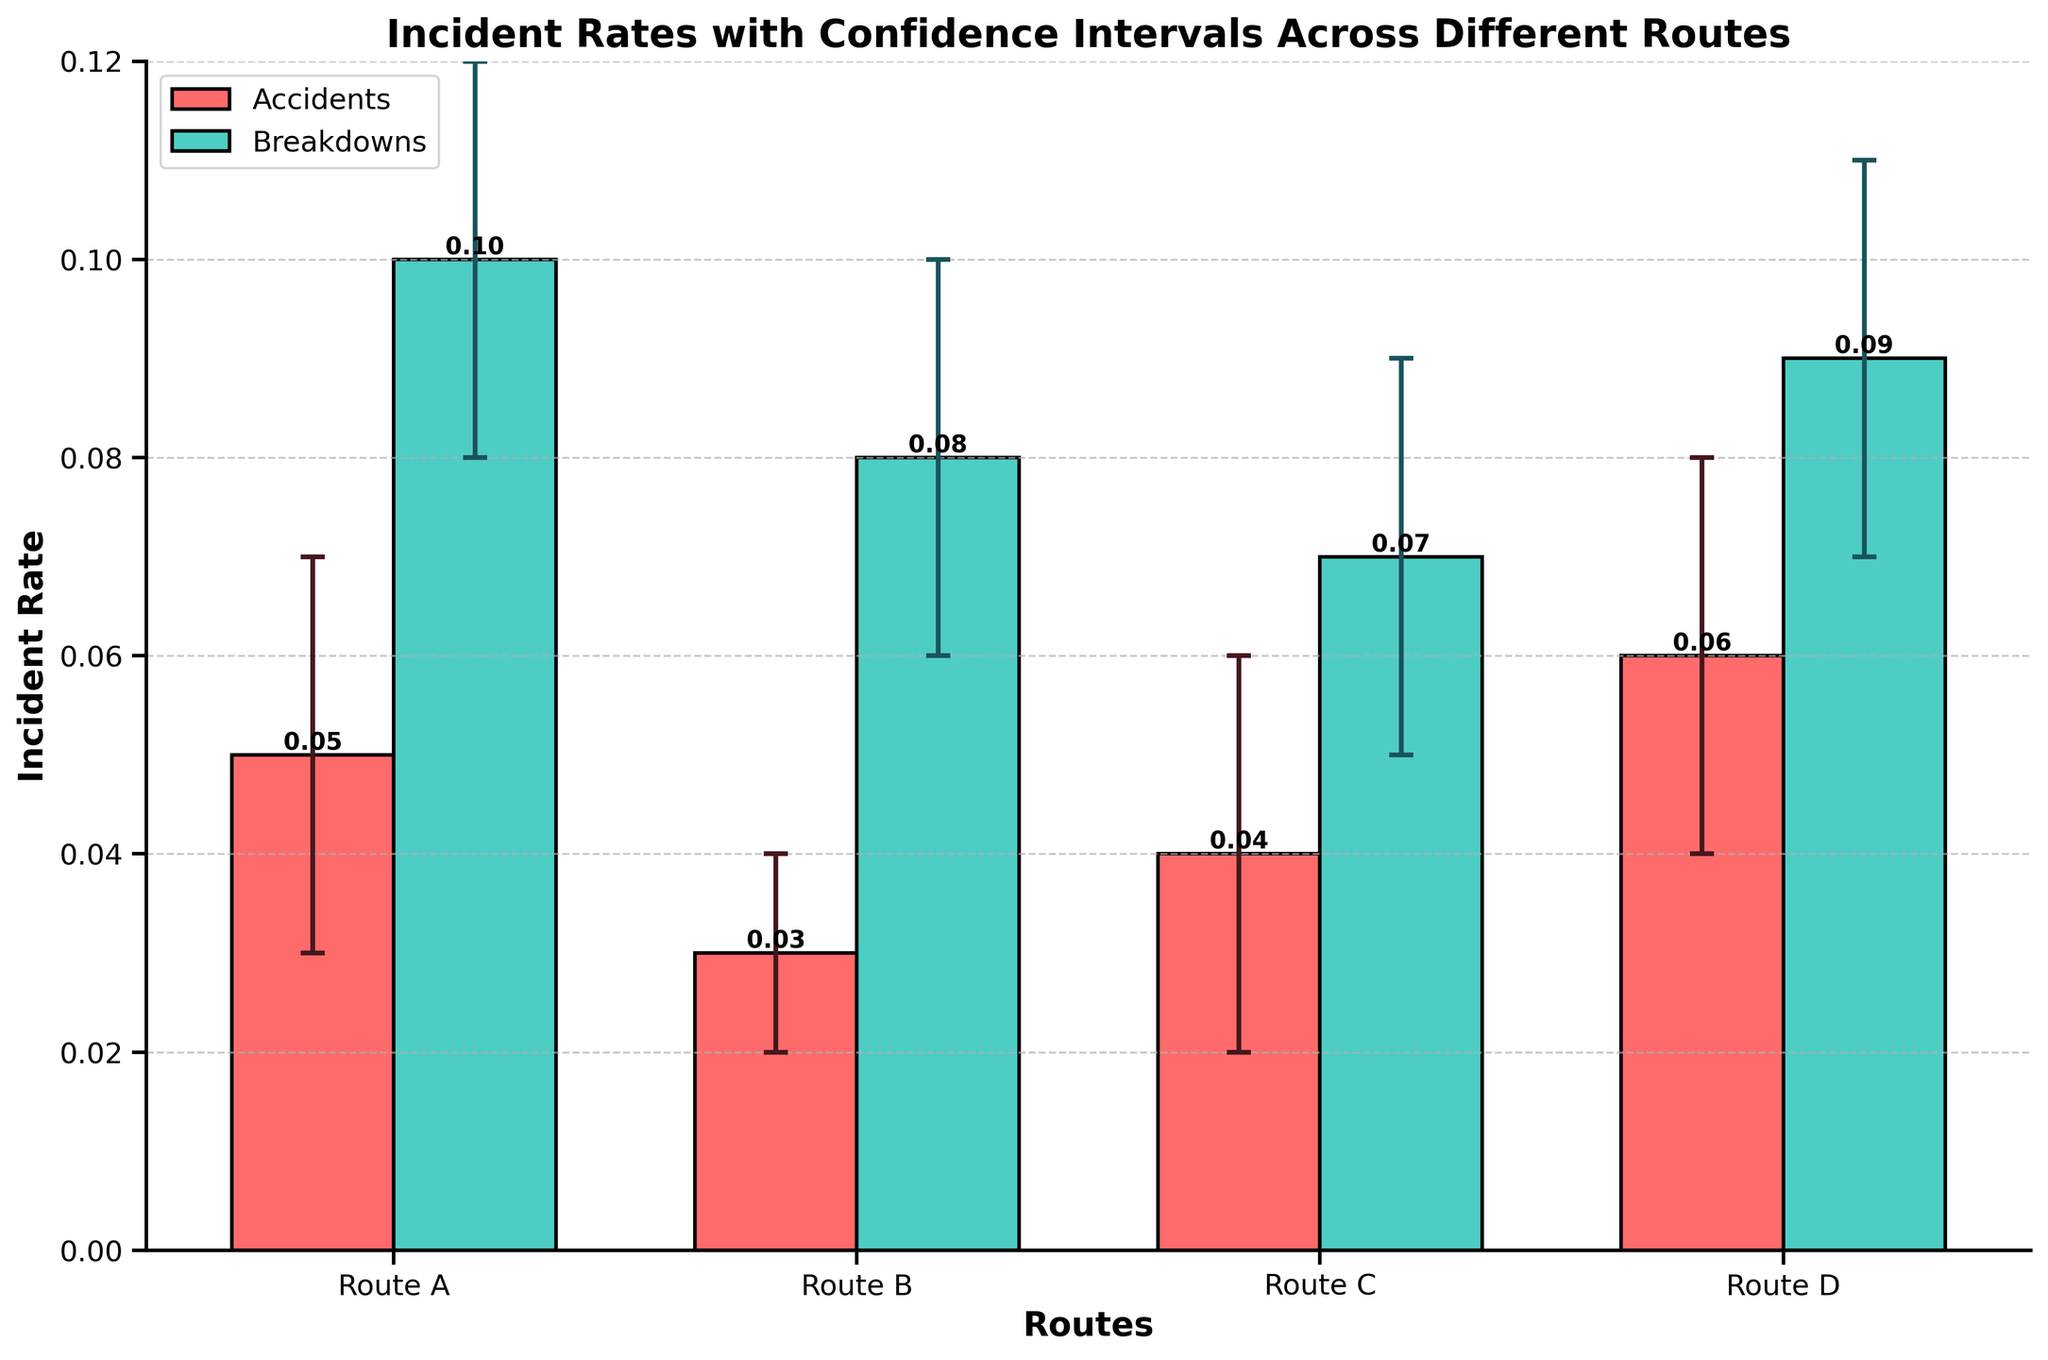What is the title of the figure? The title is usually presented at the top of the figure and summarizes the content of the chart. In this case, it states the main subject of the chart.
Answer: Incident Rates with Confidence Intervals Across Different Routes Which route has the highest average incident rate? To find the highest average incident rate, we need to calculate the average for each route. Route A has (0.05+0.10)/2 = 0.075, Route B has (0.03+0.08)/2 = 0.055, Route C has (0.04+0.07)/2 = 0.055, Route D has (0.06+0.09)/2 = 0.075. Thus, Routes A and D have the highest average incident rate.
Answer: Route A and Route D What is the incident rate of accidents in Route D? To determine this, we can refer to the bar corresponding to accidents for Route D. The bar's height indicates the rate of incidents.
Answer: 0.06 Which incident type has more variability in Route A, accidents or breakdowns? Variability can be assessed by the length of the error bars. For Route A, the error bars for accidents range from 0.03 to 0.07, while breakdowns range from 0.08 to 0.12. The length of the error bars for accidents is 0.07 - 0.03 = 0.04 and for breakdowns is 0.12 - 0.08 = 0.04. Since they are equal, both incident types have the same variability.
Answer: Both have the same variability How do the confidence intervals for breakdowns in Route B compare to those in Route C? We look at the error bars for breakdowns in Routes B and C. In Route B, the interval is from 0.06 to 0.10, and in Route C, the interval is from 0.05 to 0.09. Comparing the ranges, the confidence interval for Route B (0.04) is slightly narrower than that of Route C (0.04) and starts at a higher value.
Answer: Route B is narrower and starts higher Which route has the lowest incident rate of breakdowns? To determine this, we compare the breakdown rates across all routes. The rates are Route A: 0.10, Route B: 0.08, Route C: 0.07, and Route D: 0.09. The lowest rate is in Route C.
Answer: Route C What is the range of the confidence interval for accidents in Route C? The confidence interval for accidents in Route C is given from 0.02 to 0.06. The range is the upper limit minus the lower limit: 0.06 - 0.02 = 0.04.
Answer: 0.04 Which incident type has a greater combined rate across all routes, accidents or breakdowns? To find the combined rate, we sum the incident rates for each type across all routes. The total for accidents is 0.05 + 0.03 + 0.04 + 0.06 = 0.18, and for breakdowns, it is 0.10 + 0.08 + 0.07 + 0.09 = 0.34. Therefore, breakdowns have a greater combined rate.
Answer: Breakdowns Between Routes B and C, which has a higher rate of accidents? The bars representing accidents for Routes B and C are compared. Route B's rate is 0.03, while Route C's rate is 0.04. Therefore, Route C has a higher rate of accidents.
Answer: Route C 